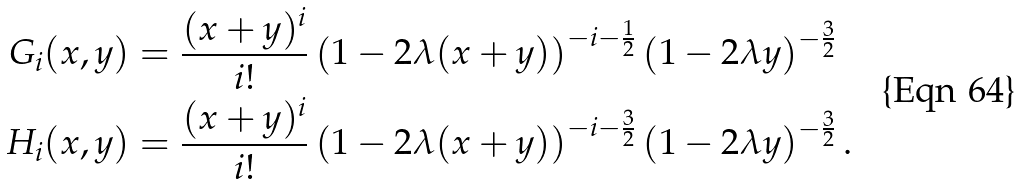Convert formula to latex. <formula><loc_0><loc_0><loc_500><loc_500>G _ { i } ( x , y ) & = \frac { ( x + y ) ^ { i } } { i ! } \left ( 1 - 2 \lambda ( x + y ) \right ) ^ { - i - \frac { 1 } { 2 } } \left ( 1 - 2 \lambda y \right ) ^ { - \frac { 3 } { 2 } } \\ H _ { i } ( x , y ) & = \frac { ( x + y ) ^ { i } } { i ! } \left ( 1 - 2 \lambda ( x + y ) \right ) ^ { - i - \frac { 3 } { 2 } } \left ( 1 - 2 \lambda y \right ) ^ { - \frac { 3 } { 2 } } .</formula> 